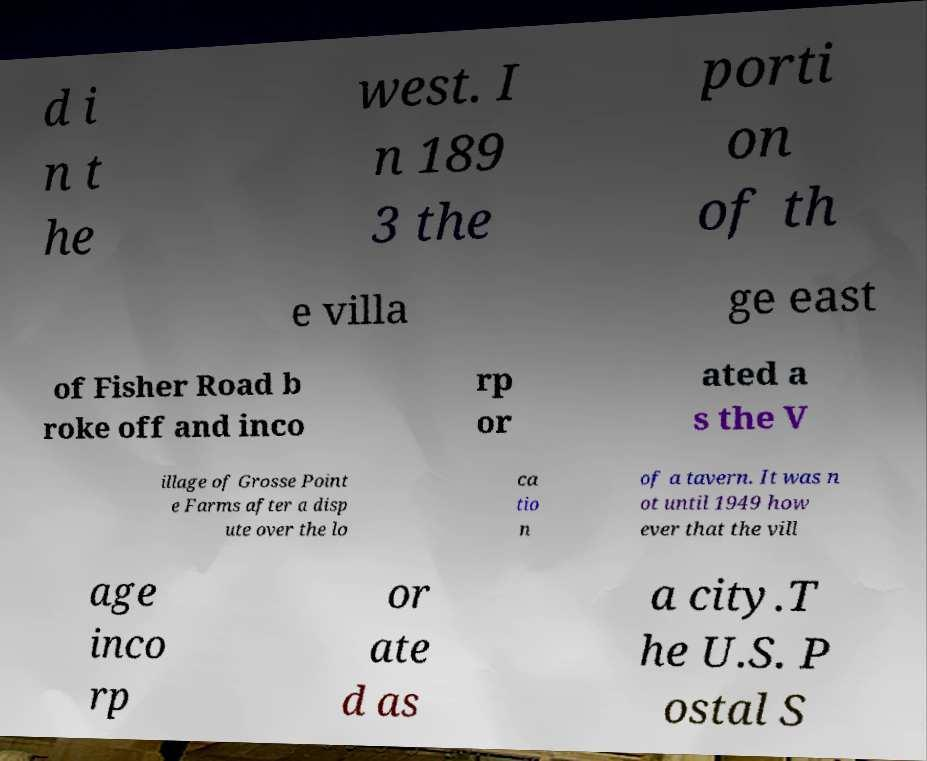For documentation purposes, I need the text within this image transcribed. Could you provide that? d i n t he west. I n 189 3 the porti on of th e villa ge east of Fisher Road b roke off and inco rp or ated a s the V illage of Grosse Point e Farms after a disp ute over the lo ca tio n of a tavern. It was n ot until 1949 how ever that the vill age inco rp or ate d as a city.T he U.S. P ostal S 